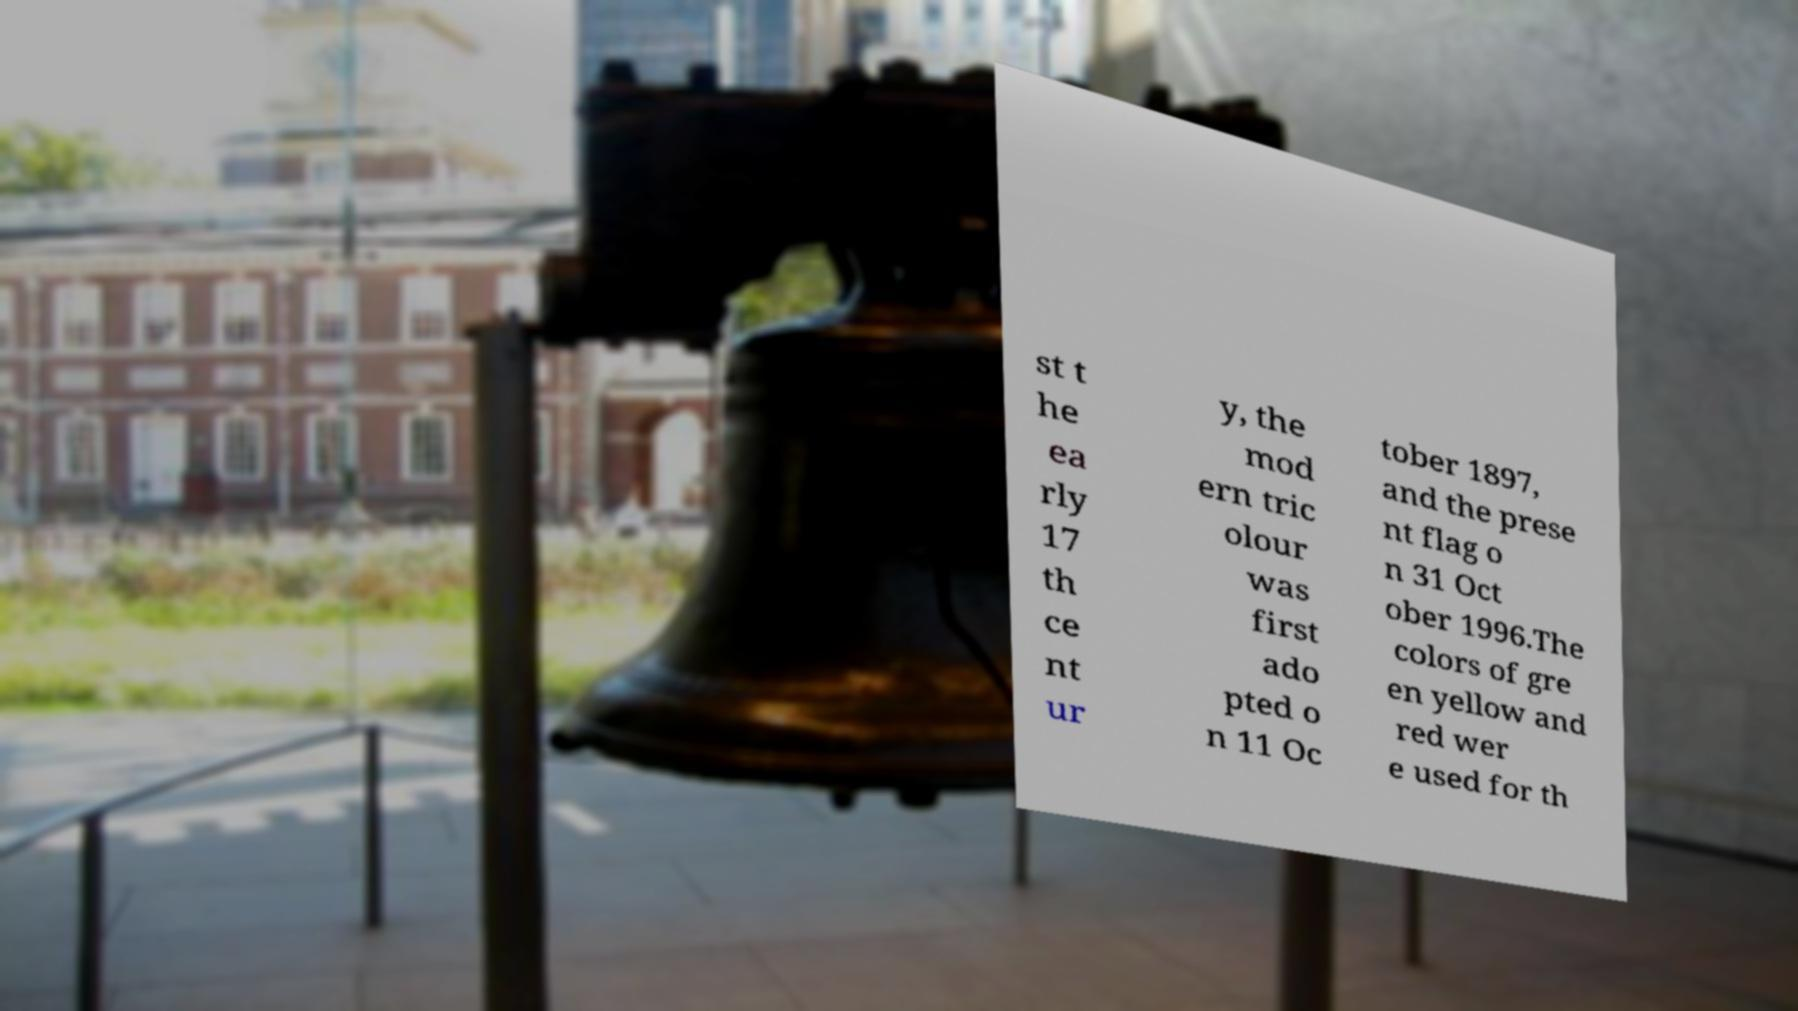For documentation purposes, I need the text within this image transcribed. Could you provide that? st t he ea rly 17 th ce nt ur y, the mod ern tric olour was first ado pted o n 11 Oc tober 1897, and the prese nt flag o n 31 Oct ober 1996.The colors of gre en yellow and red wer e used for th 